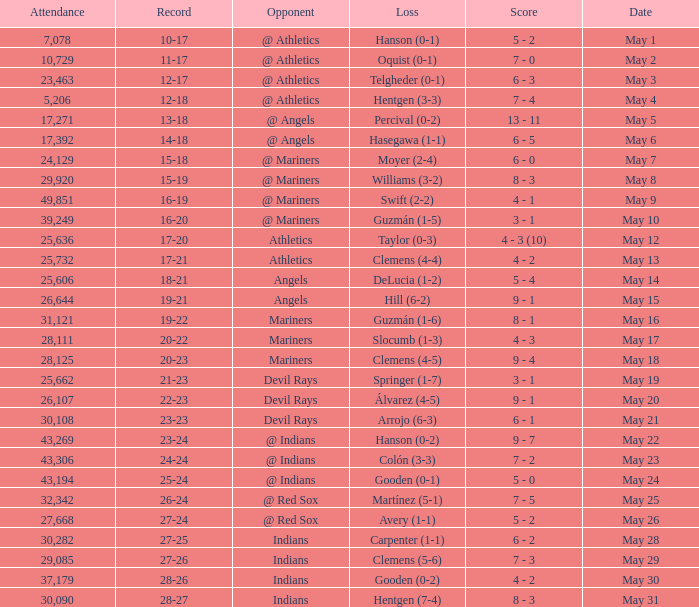Who lost on May 31? Hentgen (7-4). 